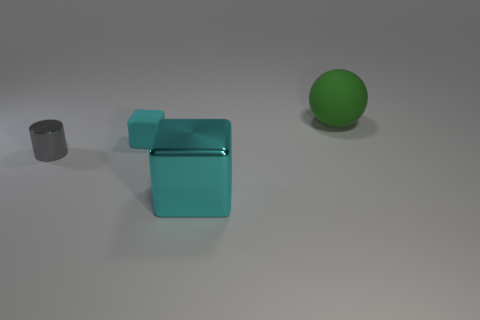Add 1 big shiny objects. How many objects exist? 5 Subtract all balls. How many objects are left? 3 Add 3 shiny cubes. How many shiny cubes exist? 4 Subtract 0 blue balls. How many objects are left? 4 Subtract all gray shiny cylinders. Subtract all big cyan metallic cubes. How many objects are left? 2 Add 1 cubes. How many cubes are left? 3 